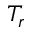Convert formula to latex. <formula><loc_0><loc_0><loc_500><loc_500>T _ { r }</formula> 